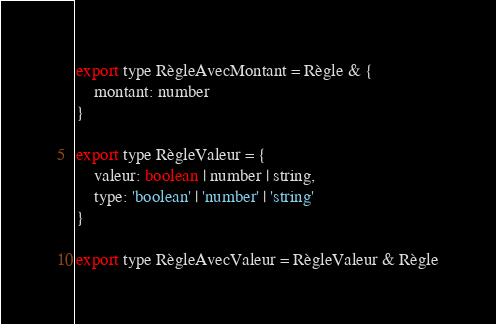Convert code to text. <code><loc_0><loc_0><loc_500><loc_500><_JavaScript_>export type RègleAvecMontant = Règle & {
	montant: number
}

export type RègleValeur = {
	valeur: boolean | number | string,
	type: 'boolean' | 'number' | 'string'
}

export type RègleAvecValeur = RègleValeur & Règle
</code> 